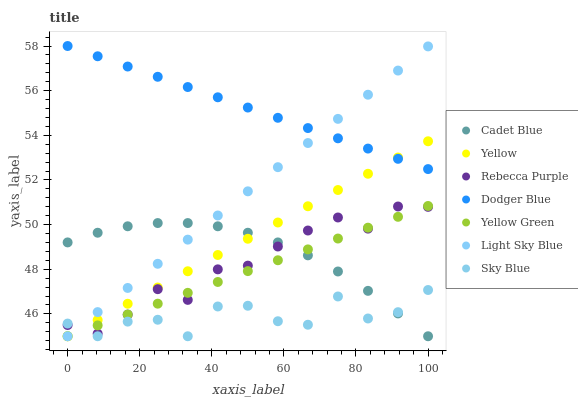Does Sky Blue have the minimum area under the curve?
Answer yes or no. Yes. Does Dodger Blue have the maximum area under the curve?
Answer yes or no. Yes. Does Yellow Green have the minimum area under the curve?
Answer yes or no. No. Does Yellow Green have the maximum area under the curve?
Answer yes or no. No. Is Yellow Green the smoothest?
Answer yes or no. Yes. Is Sky Blue the roughest?
Answer yes or no. Yes. Is Yellow the smoothest?
Answer yes or no. No. Is Yellow the roughest?
Answer yes or no. No. Does Cadet Blue have the lowest value?
Answer yes or no. Yes. Does Dodger Blue have the lowest value?
Answer yes or no. No. Does Dodger Blue have the highest value?
Answer yes or no. Yes. Does Yellow Green have the highest value?
Answer yes or no. No. Is Sky Blue less than Dodger Blue?
Answer yes or no. Yes. Is Dodger Blue greater than Yellow Green?
Answer yes or no. Yes. Does Light Sky Blue intersect Rebecca Purple?
Answer yes or no. Yes. Is Light Sky Blue less than Rebecca Purple?
Answer yes or no. No. Is Light Sky Blue greater than Rebecca Purple?
Answer yes or no. No. Does Sky Blue intersect Dodger Blue?
Answer yes or no. No. 